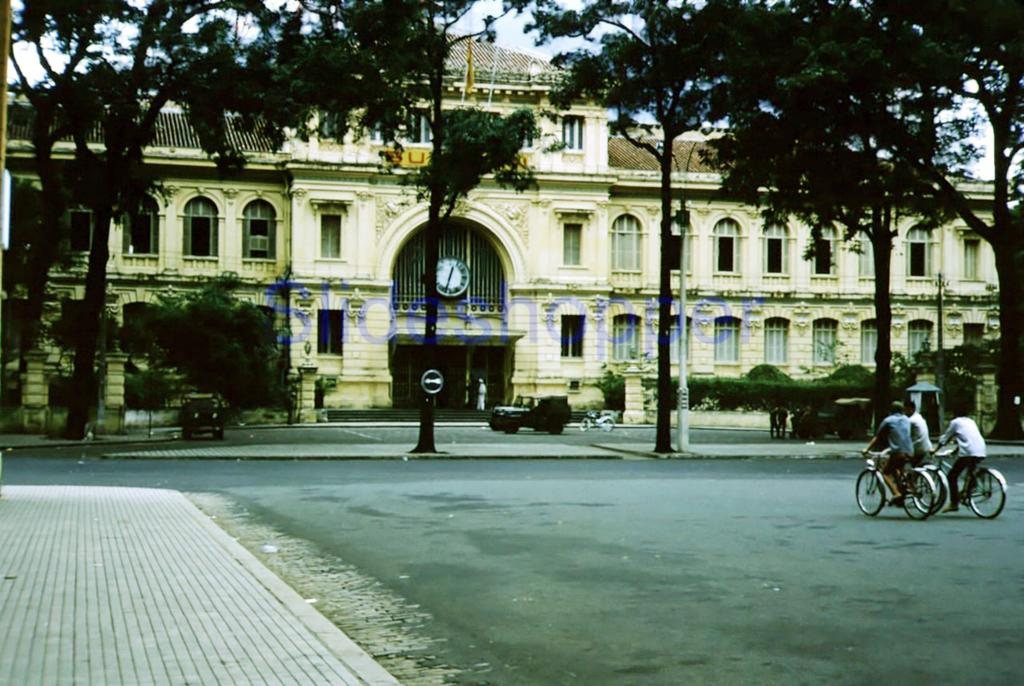What are the people in the image doing? The people in the image are riding bicycles on the road. What can be seen in the background of the image? In the background, there are boards, poles, vehicles, people, trees, a building, a clock, and plants. The sky is also visible. Can you describe the setting of the image? The image is set on a road with a variety of background elements, including a mix of natural and man-made structures. What type of meal is being prepared by the people in the image? There is no indication in the image that people are preparing a meal; they are riding bicycles. How does the clock in the image express its dislike for the people riding bicycles? The clock in the image is an inanimate object and does not express emotions like hate. 